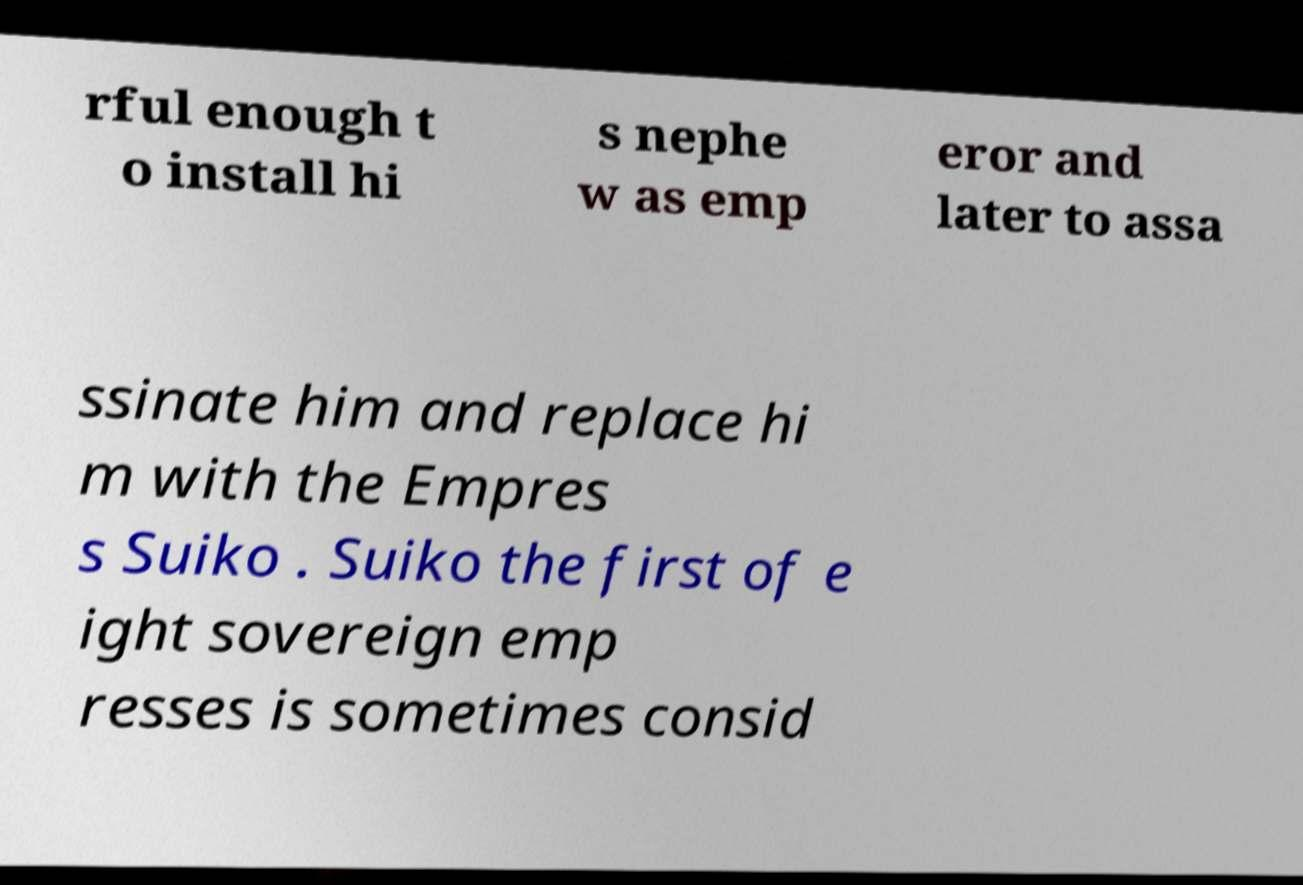What messages or text are displayed in this image? I need them in a readable, typed format. rful enough t o install hi s nephe w as emp eror and later to assa ssinate him and replace hi m with the Empres s Suiko . Suiko the first of e ight sovereign emp resses is sometimes consid 